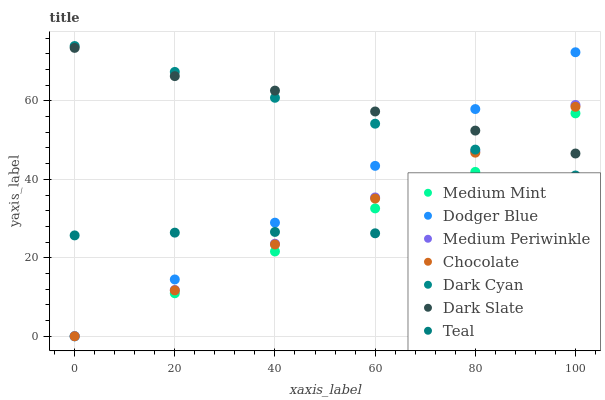Does Teal have the minimum area under the curve?
Answer yes or no. Yes. Does Dark Slate have the maximum area under the curve?
Answer yes or no. Yes. Does Medium Periwinkle have the minimum area under the curve?
Answer yes or no. No. Does Medium Periwinkle have the maximum area under the curve?
Answer yes or no. No. Is Dodger Blue the smoothest?
Answer yes or no. Yes. Is Medium Mint the roughest?
Answer yes or no. Yes. Is Medium Periwinkle the smoothest?
Answer yes or no. No. Is Medium Periwinkle the roughest?
Answer yes or no. No. Does Medium Mint have the lowest value?
Answer yes or no. Yes. Does Dark Slate have the lowest value?
Answer yes or no. No. Does Dark Cyan have the highest value?
Answer yes or no. Yes. Does Medium Periwinkle have the highest value?
Answer yes or no. No. Is Teal less than Dark Cyan?
Answer yes or no. Yes. Is Dark Slate greater than Teal?
Answer yes or no. Yes. Does Dark Cyan intersect Chocolate?
Answer yes or no. Yes. Is Dark Cyan less than Chocolate?
Answer yes or no. No. Is Dark Cyan greater than Chocolate?
Answer yes or no. No. Does Teal intersect Dark Cyan?
Answer yes or no. No. 